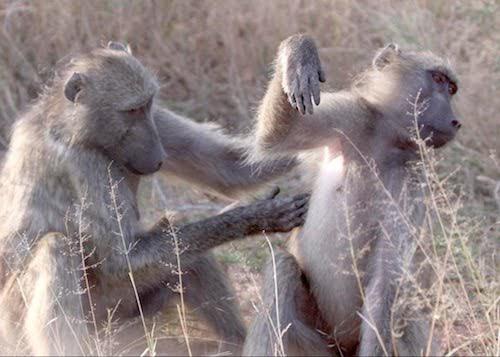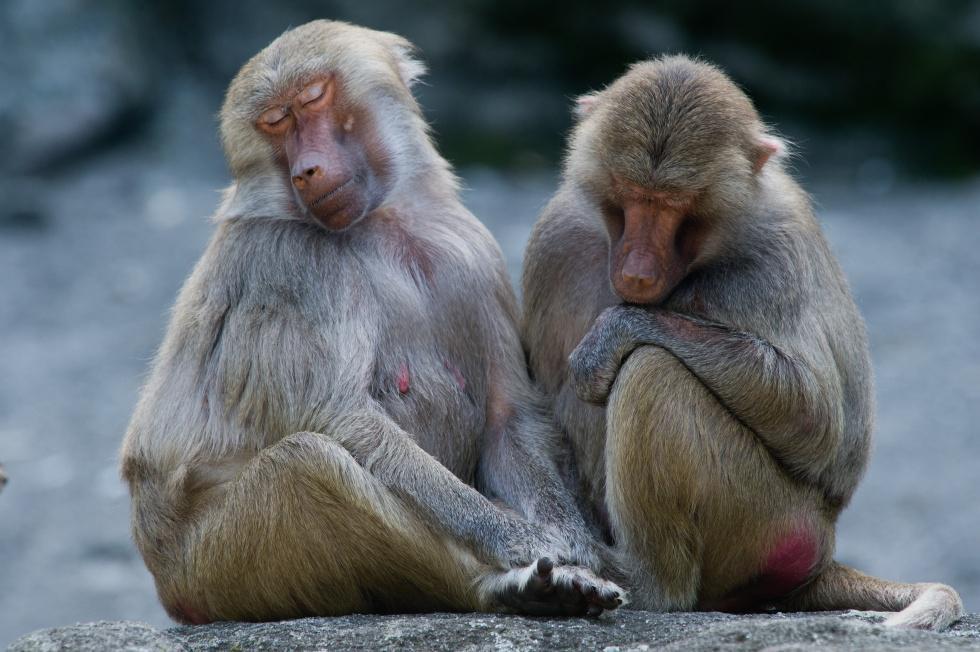The first image is the image on the left, the second image is the image on the right. Evaluate the accuracy of this statement regarding the images: "In the image on the left, there are only 2 monkeys and they have their heads turned in the same direction.". Is it true? Answer yes or no. Yes. The first image is the image on the left, the second image is the image on the right. Considering the images on both sides, is "Each image shows exactly two baboons interacting, and the left image shows one baboon grooming the fur of a baboon with its head lowered and paws down." valid? Answer yes or no. No. 